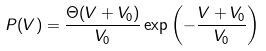Convert formula to latex. <formula><loc_0><loc_0><loc_500><loc_500>P ( V ) = \frac { \Theta ( V + V _ { 0 } ) } { V _ { 0 } } \exp { \left ( - \frac { V + V _ { 0 } } { V _ { 0 } } \right ) }</formula> 